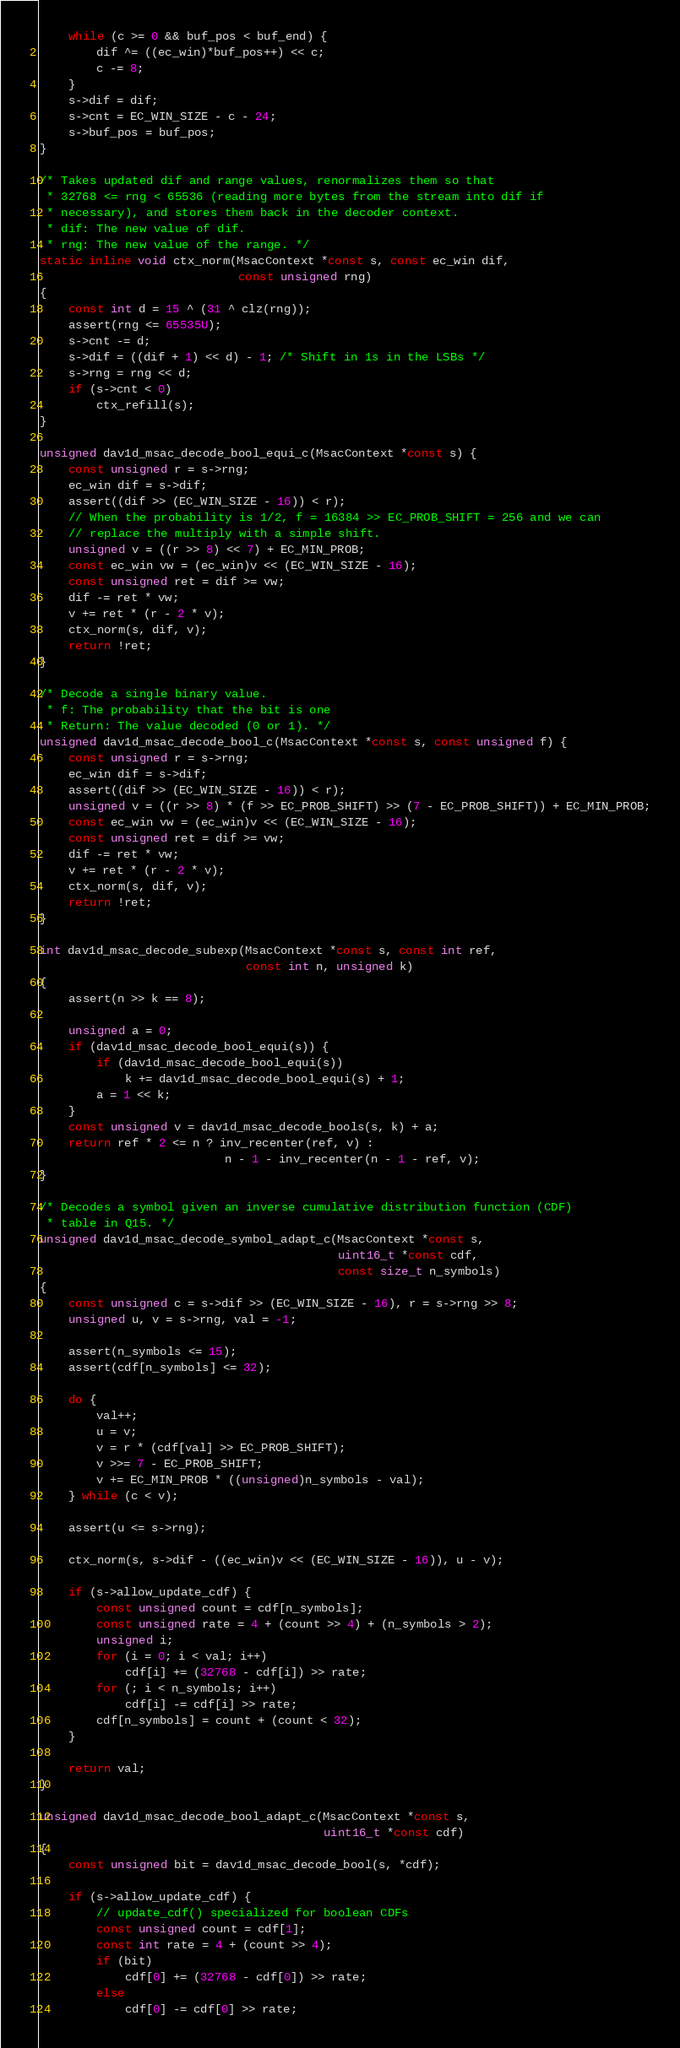<code> <loc_0><loc_0><loc_500><loc_500><_C_>    while (c >= 0 && buf_pos < buf_end) {
        dif ^= ((ec_win)*buf_pos++) << c;
        c -= 8;
    }
    s->dif = dif;
    s->cnt = EC_WIN_SIZE - c - 24;
    s->buf_pos = buf_pos;
}

/* Takes updated dif and range values, renormalizes them so that
 * 32768 <= rng < 65536 (reading more bytes from the stream into dif if
 * necessary), and stores them back in the decoder context.
 * dif: The new value of dif.
 * rng: The new value of the range. */
static inline void ctx_norm(MsacContext *const s, const ec_win dif,
                            const unsigned rng)
{
    const int d = 15 ^ (31 ^ clz(rng));
    assert(rng <= 65535U);
    s->cnt -= d;
    s->dif = ((dif + 1) << d) - 1; /* Shift in 1s in the LSBs */
    s->rng = rng << d;
    if (s->cnt < 0)
        ctx_refill(s);
}

unsigned dav1d_msac_decode_bool_equi_c(MsacContext *const s) {
    const unsigned r = s->rng;
    ec_win dif = s->dif;
    assert((dif >> (EC_WIN_SIZE - 16)) < r);
    // When the probability is 1/2, f = 16384 >> EC_PROB_SHIFT = 256 and we can
    // replace the multiply with a simple shift.
    unsigned v = ((r >> 8) << 7) + EC_MIN_PROB;
    const ec_win vw = (ec_win)v << (EC_WIN_SIZE - 16);
    const unsigned ret = dif >= vw;
    dif -= ret * vw;
    v += ret * (r - 2 * v);
    ctx_norm(s, dif, v);
    return !ret;
}

/* Decode a single binary value.
 * f: The probability that the bit is one
 * Return: The value decoded (0 or 1). */
unsigned dav1d_msac_decode_bool_c(MsacContext *const s, const unsigned f) {
    const unsigned r = s->rng;
    ec_win dif = s->dif;
    assert((dif >> (EC_WIN_SIZE - 16)) < r);
    unsigned v = ((r >> 8) * (f >> EC_PROB_SHIFT) >> (7 - EC_PROB_SHIFT)) + EC_MIN_PROB;
    const ec_win vw = (ec_win)v << (EC_WIN_SIZE - 16);
    const unsigned ret = dif >= vw;
    dif -= ret * vw;
    v += ret * (r - 2 * v);
    ctx_norm(s, dif, v);
    return !ret;
}

int dav1d_msac_decode_subexp(MsacContext *const s, const int ref,
                             const int n, unsigned k)
{
    assert(n >> k == 8);

    unsigned a = 0;
    if (dav1d_msac_decode_bool_equi(s)) {
        if (dav1d_msac_decode_bool_equi(s))
            k += dav1d_msac_decode_bool_equi(s) + 1;
        a = 1 << k;
    }
    const unsigned v = dav1d_msac_decode_bools(s, k) + a;
    return ref * 2 <= n ? inv_recenter(ref, v) :
                          n - 1 - inv_recenter(n - 1 - ref, v);
}

/* Decodes a symbol given an inverse cumulative distribution function (CDF)
 * table in Q15. */
unsigned dav1d_msac_decode_symbol_adapt_c(MsacContext *const s,
                                          uint16_t *const cdf,
                                          const size_t n_symbols)
{
    const unsigned c = s->dif >> (EC_WIN_SIZE - 16), r = s->rng >> 8;
    unsigned u, v = s->rng, val = -1;

    assert(n_symbols <= 15);
    assert(cdf[n_symbols] <= 32);

    do {
        val++;
        u = v;
        v = r * (cdf[val] >> EC_PROB_SHIFT);
        v >>= 7 - EC_PROB_SHIFT;
        v += EC_MIN_PROB * ((unsigned)n_symbols - val);
    } while (c < v);

    assert(u <= s->rng);

    ctx_norm(s, s->dif - ((ec_win)v << (EC_WIN_SIZE - 16)), u - v);

    if (s->allow_update_cdf) {
        const unsigned count = cdf[n_symbols];
        const unsigned rate = 4 + (count >> 4) + (n_symbols > 2);
        unsigned i;
        for (i = 0; i < val; i++)
            cdf[i] += (32768 - cdf[i]) >> rate;
        for (; i < n_symbols; i++)
            cdf[i] -= cdf[i] >> rate;
        cdf[n_symbols] = count + (count < 32);
    }

    return val;
}

unsigned dav1d_msac_decode_bool_adapt_c(MsacContext *const s,
                                        uint16_t *const cdf)
{
    const unsigned bit = dav1d_msac_decode_bool(s, *cdf);

    if (s->allow_update_cdf) {
        // update_cdf() specialized for boolean CDFs
        const unsigned count = cdf[1];
        const int rate = 4 + (count >> 4);
        if (bit)
            cdf[0] += (32768 - cdf[0]) >> rate;
        else
            cdf[0] -= cdf[0] >> rate;</code> 